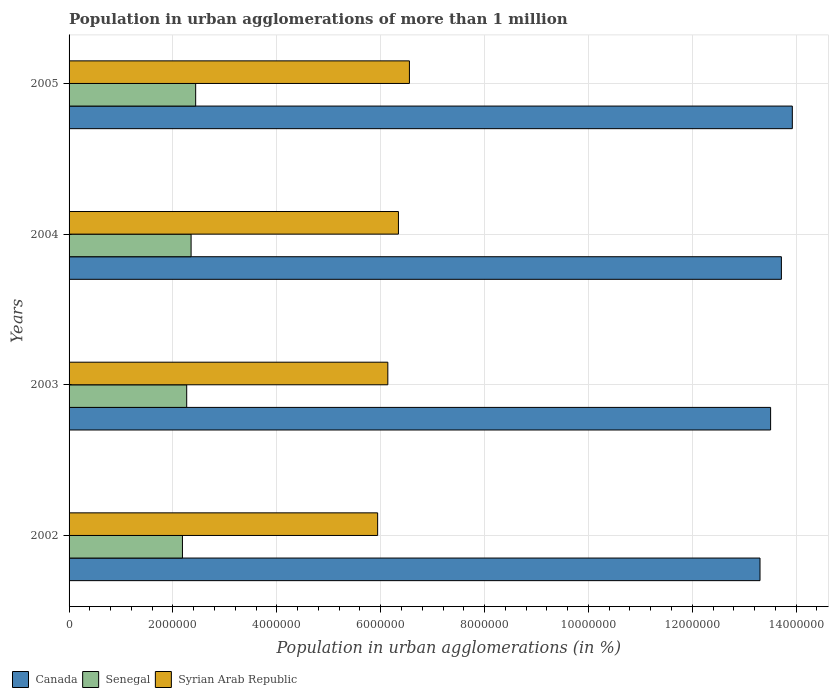How many different coloured bars are there?
Offer a very short reply. 3. How many groups of bars are there?
Your answer should be compact. 4. Are the number of bars per tick equal to the number of legend labels?
Keep it short and to the point. Yes. Are the number of bars on each tick of the Y-axis equal?
Give a very brief answer. Yes. How many bars are there on the 2nd tick from the top?
Keep it short and to the point. 3. How many bars are there on the 3rd tick from the bottom?
Your answer should be very brief. 3. What is the label of the 4th group of bars from the top?
Make the answer very short. 2002. What is the population in urban agglomerations in Senegal in 2003?
Your answer should be very brief. 2.26e+06. Across all years, what is the maximum population in urban agglomerations in Syrian Arab Republic?
Offer a terse response. 6.55e+06. Across all years, what is the minimum population in urban agglomerations in Senegal?
Offer a terse response. 2.18e+06. What is the total population in urban agglomerations in Canada in the graph?
Ensure brevity in your answer.  5.45e+07. What is the difference between the population in urban agglomerations in Senegal in 2002 and that in 2004?
Give a very brief answer. -1.66e+05. What is the difference between the population in urban agglomerations in Syrian Arab Republic in 2004 and the population in urban agglomerations in Canada in 2005?
Ensure brevity in your answer.  -7.58e+06. What is the average population in urban agglomerations in Senegal per year?
Your answer should be very brief. 2.31e+06. In the year 2003, what is the difference between the population in urban agglomerations in Syrian Arab Republic and population in urban agglomerations in Senegal?
Offer a terse response. 3.87e+06. What is the ratio of the population in urban agglomerations in Senegal in 2002 to that in 2005?
Your answer should be compact. 0.9. Is the population in urban agglomerations in Syrian Arab Republic in 2002 less than that in 2005?
Your answer should be compact. Yes. What is the difference between the highest and the second highest population in urban agglomerations in Canada?
Your response must be concise. 2.10e+05. What is the difference between the highest and the lowest population in urban agglomerations in Canada?
Your response must be concise. 6.22e+05. What does the 3rd bar from the top in 2004 represents?
Make the answer very short. Canada. What does the 1st bar from the bottom in 2002 represents?
Give a very brief answer. Canada. How many bars are there?
Your response must be concise. 12. How many years are there in the graph?
Offer a very short reply. 4. What is the difference between two consecutive major ticks on the X-axis?
Ensure brevity in your answer.  2.00e+06. Are the values on the major ticks of X-axis written in scientific E-notation?
Provide a succinct answer. No. Does the graph contain any zero values?
Your response must be concise. No. Does the graph contain grids?
Give a very brief answer. Yes. Where does the legend appear in the graph?
Your answer should be compact. Bottom left. What is the title of the graph?
Provide a succinct answer. Population in urban agglomerations of more than 1 million. What is the label or title of the X-axis?
Give a very brief answer. Population in urban agglomerations (in %). What is the Population in urban agglomerations (in %) in Canada in 2002?
Offer a terse response. 1.33e+07. What is the Population in urban agglomerations (in %) in Senegal in 2002?
Offer a terse response. 2.18e+06. What is the Population in urban agglomerations (in %) of Syrian Arab Republic in 2002?
Ensure brevity in your answer.  5.94e+06. What is the Population in urban agglomerations (in %) in Canada in 2003?
Your response must be concise. 1.35e+07. What is the Population in urban agglomerations (in %) of Senegal in 2003?
Your answer should be compact. 2.26e+06. What is the Population in urban agglomerations (in %) in Syrian Arab Republic in 2003?
Give a very brief answer. 6.14e+06. What is the Population in urban agglomerations (in %) of Canada in 2004?
Provide a succinct answer. 1.37e+07. What is the Population in urban agglomerations (in %) in Senegal in 2004?
Offer a very short reply. 2.35e+06. What is the Population in urban agglomerations (in %) of Syrian Arab Republic in 2004?
Provide a short and direct response. 6.34e+06. What is the Population in urban agglomerations (in %) in Canada in 2005?
Give a very brief answer. 1.39e+07. What is the Population in urban agglomerations (in %) in Senegal in 2005?
Your response must be concise. 2.44e+06. What is the Population in urban agglomerations (in %) in Syrian Arab Republic in 2005?
Offer a terse response. 6.55e+06. Across all years, what is the maximum Population in urban agglomerations (in %) in Canada?
Offer a very short reply. 1.39e+07. Across all years, what is the maximum Population in urban agglomerations (in %) of Senegal?
Ensure brevity in your answer.  2.44e+06. Across all years, what is the maximum Population in urban agglomerations (in %) in Syrian Arab Republic?
Provide a short and direct response. 6.55e+06. Across all years, what is the minimum Population in urban agglomerations (in %) of Canada?
Make the answer very short. 1.33e+07. Across all years, what is the minimum Population in urban agglomerations (in %) of Senegal?
Make the answer very short. 2.18e+06. Across all years, what is the minimum Population in urban agglomerations (in %) in Syrian Arab Republic?
Ensure brevity in your answer.  5.94e+06. What is the total Population in urban agglomerations (in %) of Canada in the graph?
Your answer should be compact. 5.45e+07. What is the total Population in urban agglomerations (in %) of Senegal in the graph?
Offer a terse response. 9.24e+06. What is the total Population in urban agglomerations (in %) in Syrian Arab Republic in the graph?
Make the answer very short. 2.50e+07. What is the difference between the Population in urban agglomerations (in %) in Canada in 2002 and that in 2003?
Provide a short and direct response. -2.04e+05. What is the difference between the Population in urban agglomerations (in %) in Senegal in 2002 and that in 2003?
Your answer should be compact. -8.17e+04. What is the difference between the Population in urban agglomerations (in %) of Syrian Arab Republic in 2002 and that in 2003?
Your answer should be very brief. -1.96e+05. What is the difference between the Population in urban agglomerations (in %) of Canada in 2002 and that in 2004?
Provide a short and direct response. -4.12e+05. What is the difference between the Population in urban agglomerations (in %) of Senegal in 2002 and that in 2004?
Ensure brevity in your answer.  -1.66e+05. What is the difference between the Population in urban agglomerations (in %) in Syrian Arab Republic in 2002 and that in 2004?
Your response must be concise. -4.00e+05. What is the difference between the Population in urban agglomerations (in %) in Canada in 2002 and that in 2005?
Offer a terse response. -6.22e+05. What is the difference between the Population in urban agglomerations (in %) of Senegal in 2002 and that in 2005?
Provide a succinct answer. -2.54e+05. What is the difference between the Population in urban agglomerations (in %) in Syrian Arab Republic in 2002 and that in 2005?
Offer a terse response. -6.12e+05. What is the difference between the Population in urban agglomerations (in %) in Canada in 2003 and that in 2004?
Your answer should be compact. -2.08e+05. What is the difference between the Population in urban agglomerations (in %) of Senegal in 2003 and that in 2004?
Keep it short and to the point. -8.48e+04. What is the difference between the Population in urban agglomerations (in %) in Syrian Arab Republic in 2003 and that in 2004?
Give a very brief answer. -2.04e+05. What is the difference between the Population in urban agglomerations (in %) in Canada in 2003 and that in 2005?
Your answer should be very brief. -4.18e+05. What is the difference between the Population in urban agglomerations (in %) in Senegal in 2003 and that in 2005?
Provide a short and direct response. -1.73e+05. What is the difference between the Population in urban agglomerations (in %) in Syrian Arab Republic in 2003 and that in 2005?
Keep it short and to the point. -4.16e+05. What is the difference between the Population in urban agglomerations (in %) of Canada in 2004 and that in 2005?
Provide a short and direct response. -2.10e+05. What is the difference between the Population in urban agglomerations (in %) in Senegal in 2004 and that in 2005?
Offer a very short reply. -8.79e+04. What is the difference between the Population in urban agglomerations (in %) of Syrian Arab Republic in 2004 and that in 2005?
Provide a short and direct response. -2.12e+05. What is the difference between the Population in urban agglomerations (in %) of Canada in 2002 and the Population in urban agglomerations (in %) of Senegal in 2003?
Ensure brevity in your answer.  1.10e+07. What is the difference between the Population in urban agglomerations (in %) in Canada in 2002 and the Population in urban agglomerations (in %) in Syrian Arab Republic in 2003?
Give a very brief answer. 7.17e+06. What is the difference between the Population in urban agglomerations (in %) in Senegal in 2002 and the Population in urban agglomerations (in %) in Syrian Arab Republic in 2003?
Give a very brief answer. -3.95e+06. What is the difference between the Population in urban agglomerations (in %) of Canada in 2002 and the Population in urban agglomerations (in %) of Senegal in 2004?
Your answer should be very brief. 1.10e+07. What is the difference between the Population in urban agglomerations (in %) in Canada in 2002 and the Population in urban agglomerations (in %) in Syrian Arab Republic in 2004?
Ensure brevity in your answer.  6.96e+06. What is the difference between the Population in urban agglomerations (in %) in Senegal in 2002 and the Population in urban agglomerations (in %) in Syrian Arab Republic in 2004?
Your answer should be very brief. -4.16e+06. What is the difference between the Population in urban agglomerations (in %) in Canada in 2002 and the Population in urban agglomerations (in %) in Senegal in 2005?
Give a very brief answer. 1.09e+07. What is the difference between the Population in urban agglomerations (in %) of Canada in 2002 and the Population in urban agglomerations (in %) of Syrian Arab Republic in 2005?
Keep it short and to the point. 6.75e+06. What is the difference between the Population in urban agglomerations (in %) in Senegal in 2002 and the Population in urban agglomerations (in %) in Syrian Arab Republic in 2005?
Ensure brevity in your answer.  -4.37e+06. What is the difference between the Population in urban agglomerations (in %) of Canada in 2003 and the Population in urban agglomerations (in %) of Senegal in 2004?
Your answer should be compact. 1.12e+07. What is the difference between the Population in urban agglomerations (in %) of Canada in 2003 and the Population in urban agglomerations (in %) of Syrian Arab Republic in 2004?
Provide a short and direct response. 7.17e+06. What is the difference between the Population in urban agglomerations (in %) in Senegal in 2003 and the Population in urban agglomerations (in %) in Syrian Arab Republic in 2004?
Keep it short and to the point. -4.08e+06. What is the difference between the Population in urban agglomerations (in %) in Canada in 2003 and the Population in urban agglomerations (in %) in Senegal in 2005?
Provide a succinct answer. 1.11e+07. What is the difference between the Population in urban agglomerations (in %) in Canada in 2003 and the Population in urban agglomerations (in %) in Syrian Arab Republic in 2005?
Make the answer very short. 6.95e+06. What is the difference between the Population in urban agglomerations (in %) in Senegal in 2003 and the Population in urban agglomerations (in %) in Syrian Arab Republic in 2005?
Your answer should be compact. -4.29e+06. What is the difference between the Population in urban agglomerations (in %) in Canada in 2004 and the Population in urban agglomerations (in %) in Senegal in 2005?
Make the answer very short. 1.13e+07. What is the difference between the Population in urban agglomerations (in %) in Canada in 2004 and the Population in urban agglomerations (in %) in Syrian Arab Republic in 2005?
Keep it short and to the point. 7.16e+06. What is the difference between the Population in urban agglomerations (in %) in Senegal in 2004 and the Population in urban agglomerations (in %) in Syrian Arab Republic in 2005?
Your response must be concise. -4.20e+06. What is the average Population in urban agglomerations (in %) in Canada per year?
Offer a terse response. 1.36e+07. What is the average Population in urban agglomerations (in %) in Senegal per year?
Keep it short and to the point. 2.31e+06. What is the average Population in urban agglomerations (in %) in Syrian Arab Republic per year?
Make the answer very short. 6.24e+06. In the year 2002, what is the difference between the Population in urban agglomerations (in %) in Canada and Population in urban agglomerations (in %) in Senegal?
Your response must be concise. 1.11e+07. In the year 2002, what is the difference between the Population in urban agglomerations (in %) in Canada and Population in urban agglomerations (in %) in Syrian Arab Republic?
Make the answer very short. 7.36e+06. In the year 2002, what is the difference between the Population in urban agglomerations (in %) of Senegal and Population in urban agglomerations (in %) of Syrian Arab Republic?
Ensure brevity in your answer.  -3.76e+06. In the year 2003, what is the difference between the Population in urban agglomerations (in %) of Canada and Population in urban agglomerations (in %) of Senegal?
Make the answer very short. 1.12e+07. In the year 2003, what is the difference between the Population in urban agglomerations (in %) in Canada and Population in urban agglomerations (in %) in Syrian Arab Republic?
Offer a very short reply. 7.37e+06. In the year 2003, what is the difference between the Population in urban agglomerations (in %) in Senegal and Population in urban agglomerations (in %) in Syrian Arab Republic?
Provide a short and direct response. -3.87e+06. In the year 2004, what is the difference between the Population in urban agglomerations (in %) of Canada and Population in urban agglomerations (in %) of Senegal?
Give a very brief answer. 1.14e+07. In the year 2004, what is the difference between the Population in urban agglomerations (in %) in Canada and Population in urban agglomerations (in %) in Syrian Arab Republic?
Ensure brevity in your answer.  7.37e+06. In the year 2004, what is the difference between the Population in urban agglomerations (in %) in Senegal and Population in urban agglomerations (in %) in Syrian Arab Republic?
Offer a very short reply. -3.99e+06. In the year 2005, what is the difference between the Population in urban agglomerations (in %) in Canada and Population in urban agglomerations (in %) in Senegal?
Your response must be concise. 1.15e+07. In the year 2005, what is the difference between the Population in urban agglomerations (in %) of Canada and Population in urban agglomerations (in %) of Syrian Arab Republic?
Your answer should be compact. 7.37e+06. In the year 2005, what is the difference between the Population in urban agglomerations (in %) of Senegal and Population in urban agglomerations (in %) of Syrian Arab Republic?
Offer a terse response. -4.12e+06. What is the ratio of the Population in urban agglomerations (in %) of Canada in 2002 to that in 2003?
Give a very brief answer. 0.98. What is the ratio of the Population in urban agglomerations (in %) of Senegal in 2002 to that in 2003?
Offer a terse response. 0.96. What is the ratio of the Population in urban agglomerations (in %) of Syrian Arab Republic in 2002 to that in 2003?
Give a very brief answer. 0.97. What is the ratio of the Population in urban agglomerations (in %) of Canada in 2002 to that in 2004?
Keep it short and to the point. 0.97. What is the ratio of the Population in urban agglomerations (in %) of Senegal in 2002 to that in 2004?
Offer a very short reply. 0.93. What is the ratio of the Population in urban agglomerations (in %) in Syrian Arab Republic in 2002 to that in 2004?
Keep it short and to the point. 0.94. What is the ratio of the Population in urban agglomerations (in %) of Canada in 2002 to that in 2005?
Ensure brevity in your answer.  0.96. What is the ratio of the Population in urban agglomerations (in %) in Senegal in 2002 to that in 2005?
Make the answer very short. 0.9. What is the ratio of the Population in urban agglomerations (in %) in Syrian Arab Republic in 2002 to that in 2005?
Your answer should be compact. 0.91. What is the ratio of the Population in urban agglomerations (in %) of Canada in 2003 to that in 2004?
Make the answer very short. 0.98. What is the ratio of the Population in urban agglomerations (in %) of Senegal in 2003 to that in 2004?
Your response must be concise. 0.96. What is the ratio of the Population in urban agglomerations (in %) of Syrian Arab Republic in 2003 to that in 2004?
Provide a short and direct response. 0.97. What is the ratio of the Population in urban agglomerations (in %) of Canada in 2003 to that in 2005?
Make the answer very short. 0.97. What is the ratio of the Population in urban agglomerations (in %) of Senegal in 2003 to that in 2005?
Offer a very short reply. 0.93. What is the ratio of the Population in urban agglomerations (in %) in Syrian Arab Republic in 2003 to that in 2005?
Provide a succinct answer. 0.94. What is the ratio of the Population in urban agglomerations (in %) in Canada in 2004 to that in 2005?
Give a very brief answer. 0.98. What is the ratio of the Population in urban agglomerations (in %) in Senegal in 2004 to that in 2005?
Ensure brevity in your answer.  0.96. What is the ratio of the Population in urban agglomerations (in %) in Syrian Arab Republic in 2004 to that in 2005?
Your response must be concise. 0.97. What is the difference between the highest and the second highest Population in urban agglomerations (in %) in Canada?
Give a very brief answer. 2.10e+05. What is the difference between the highest and the second highest Population in urban agglomerations (in %) of Senegal?
Ensure brevity in your answer.  8.79e+04. What is the difference between the highest and the second highest Population in urban agglomerations (in %) of Syrian Arab Republic?
Provide a short and direct response. 2.12e+05. What is the difference between the highest and the lowest Population in urban agglomerations (in %) in Canada?
Provide a short and direct response. 6.22e+05. What is the difference between the highest and the lowest Population in urban agglomerations (in %) in Senegal?
Give a very brief answer. 2.54e+05. What is the difference between the highest and the lowest Population in urban agglomerations (in %) in Syrian Arab Republic?
Your answer should be very brief. 6.12e+05. 